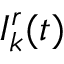Convert formula to latex. <formula><loc_0><loc_0><loc_500><loc_500>I _ { k } ^ { r } ( t )</formula> 